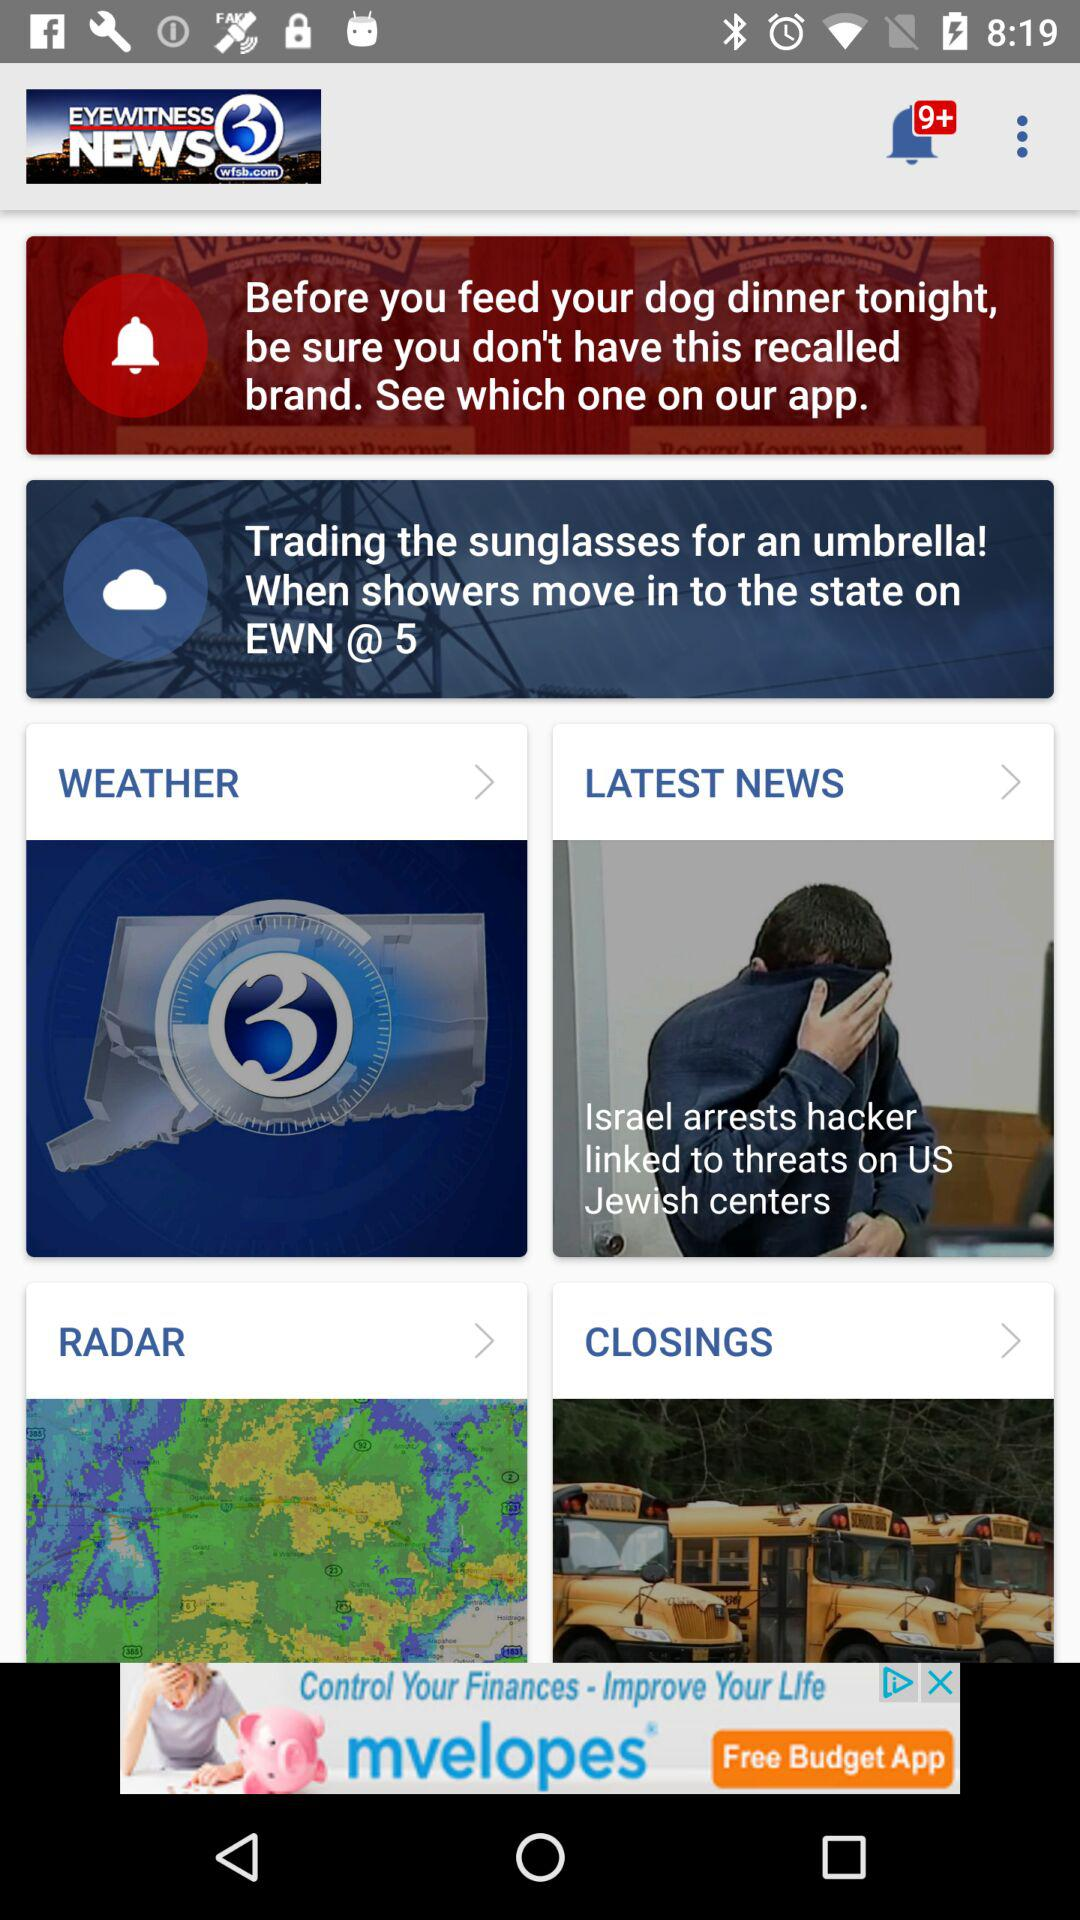How many unread notifications in total are there? There are more than 9 unread notifications. 